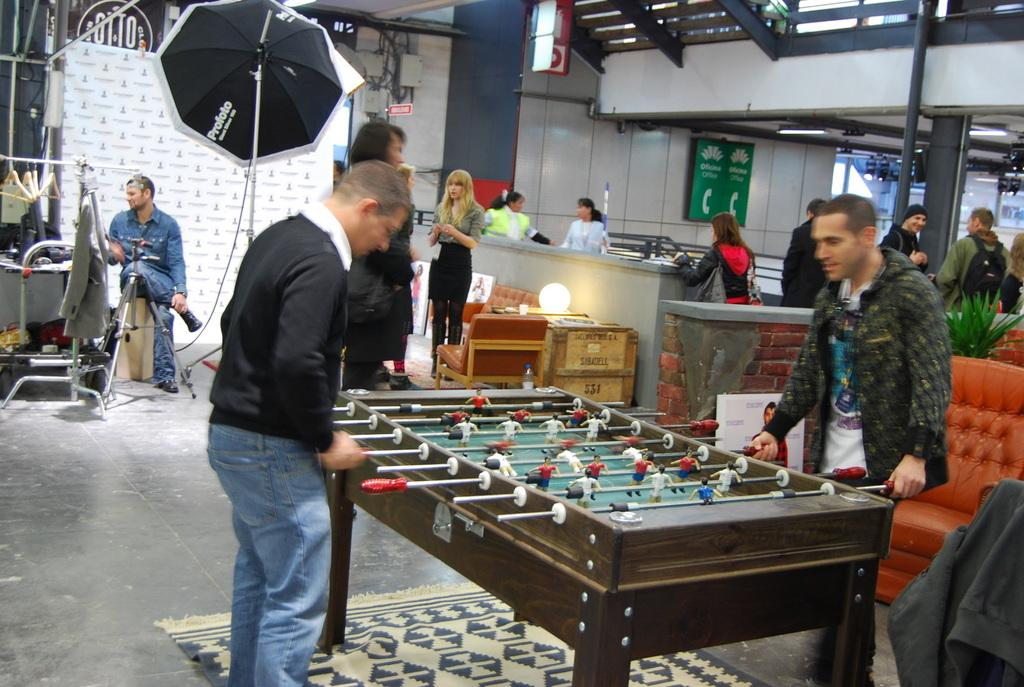What is hanging or displayed in the image? There is a banner and a poster in the image. What object is present for protection from the elements? There is an umbrella in the image. What type of structure is visible in the image? There is a wall in the image. What type of furniture is in the image? There is a sofa in the image. Who or what can be seen on the floor in the image? There are people standing on the floor in the image. Where is the scarecrow located in the image? There is no scarecrow present in the image. What season is depicted in the image? The provided facts do not mention any specific season. 